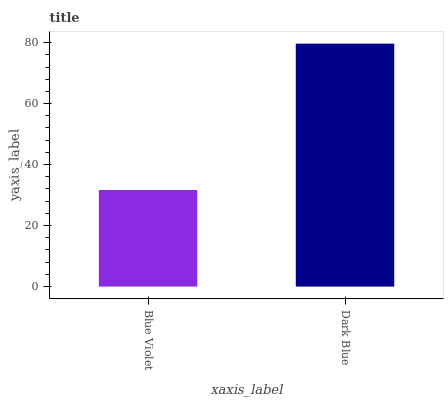Is Blue Violet the minimum?
Answer yes or no. Yes. Is Dark Blue the maximum?
Answer yes or no. Yes. Is Dark Blue the minimum?
Answer yes or no. No. Is Dark Blue greater than Blue Violet?
Answer yes or no. Yes. Is Blue Violet less than Dark Blue?
Answer yes or no. Yes. Is Blue Violet greater than Dark Blue?
Answer yes or no. No. Is Dark Blue less than Blue Violet?
Answer yes or no. No. Is Dark Blue the high median?
Answer yes or no. Yes. Is Blue Violet the low median?
Answer yes or no. Yes. Is Blue Violet the high median?
Answer yes or no. No. Is Dark Blue the low median?
Answer yes or no. No. 